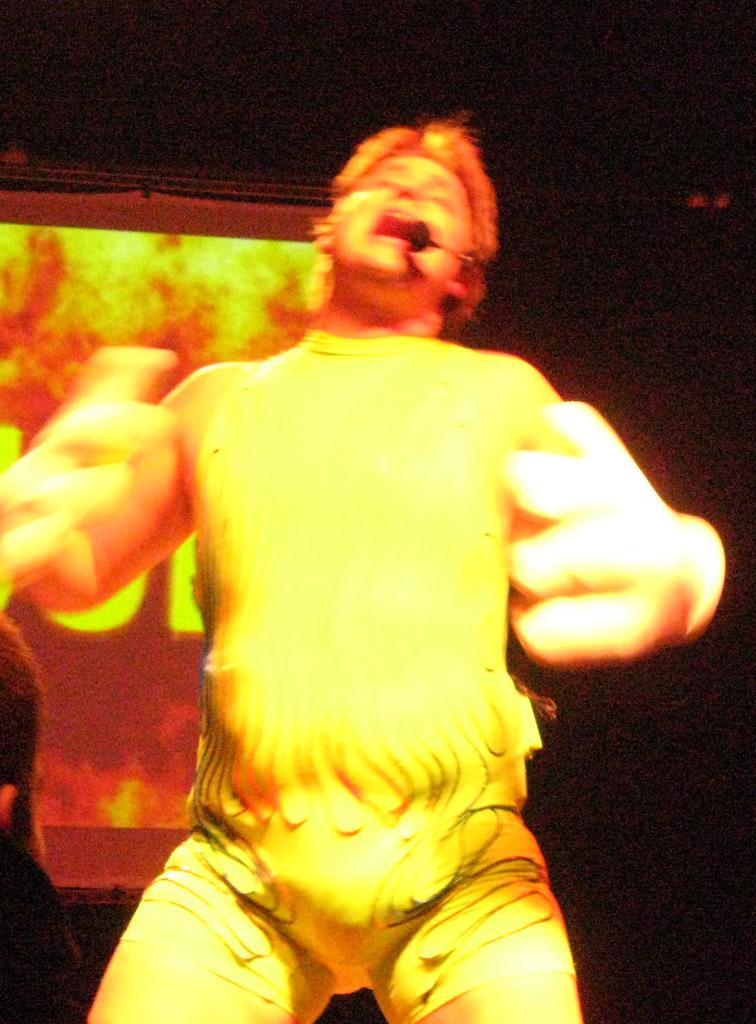Could you give a brief overview of what you see in this image? In this image I can see man is standing in the front. I can also see a mic near his mouth and I can see he is wearing yellow colour dress. In the background I can see a screen and I can see this image is little bit in dark. 